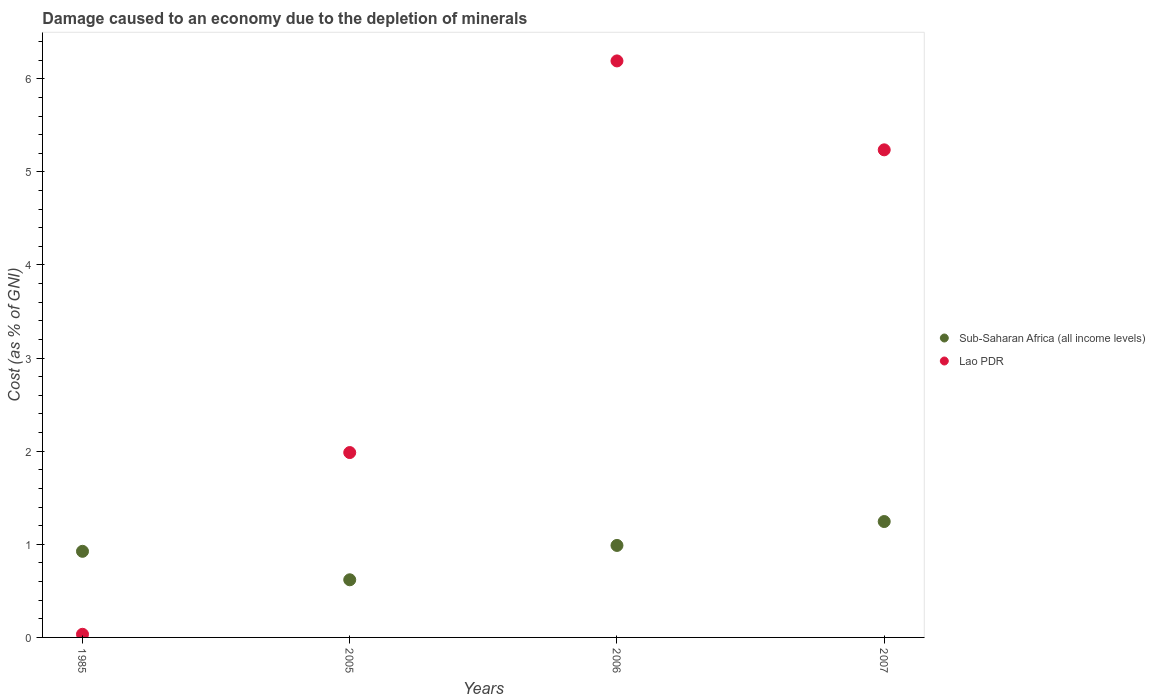How many different coloured dotlines are there?
Your response must be concise. 2. What is the cost of damage caused due to the depletion of minerals in Sub-Saharan Africa (all income levels) in 2005?
Your answer should be compact. 0.62. Across all years, what is the maximum cost of damage caused due to the depletion of minerals in Lao PDR?
Your answer should be compact. 6.19. Across all years, what is the minimum cost of damage caused due to the depletion of minerals in Lao PDR?
Offer a terse response. 0.03. In which year was the cost of damage caused due to the depletion of minerals in Lao PDR maximum?
Your response must be concise. 2006. In which year was the cost of damage caused due to the depletion of minerals in Sub-Saharan Africa (all income levels) minimum?
Provide a succinct answer. 2005. What is the total cost of damage caused due to the depletion of minerals in Lao PDR in the graph?
Make the answer very short. 13.45. What is the difference between the cost of damage caused due to the depletion of minerals in Sub-Saharan Africa (all income levels) in 2005 and that in 2007?
Your answer should be very brief. -0.63. What is the difference between the cost of damage caused due to the depletion of minerals in Sub-Saharan Africa (all income levels) in 1985 and the cost of damage caused due to the depletion of minerals in Lao PDR in 2005?
Provide a short and direct response. -1.06. What is the average cost of damage caused due to the depletion of minerals in Sub-Saharan Africa (all income levels) per year?
Give a very brief answer. 0.94. In the year 2007, what is the difference between the cost of damage caused due to the depletion of minerals in Sub-Saharan Africa (all income levels) and cost of damage caused due to the depletion of minerals in Lao PDR?
Your answer should be compact. -3.99. In how many years, is the cost of damage caused due to the depletion of minerals in Sub-Saharan Africa (all income levels) greater than 2.6 %?
Offer a terse response. 0. What is the ratio of the cost of damage caused due to the depletion of minerals in Sub-Saharan Africa (all income levels) in 1985 to that in 2005?
Give a very brief answer. 1.49. Is the cost of damage caused due to the depletion of minerals in Sub-Saharan Africa (all income levels) in 2005 less than that in 2006?
Keep it short and to the point. Yes. Is the difference between the cost of damage caused due to the depletion of minerals in Sub-Saharan Africa (all income levels) in 2005 and 2007 greater than the difference between the cost of damage caused due to the depletion of minerals in Lao PDR in 2005 and 2007?
Make the answer very short. Yes. What is the difference between the highest and the second highest cost of damage caused due to the depletion of minerals in Lao PDR?
Offer a terse response. 0.95. What is the difference between the highest and the lowest cost of damage caused due to the depletion of minerals in Sub-Saharan Africa (all income levels)?
Your answer should be compact. 0.63. In how many years, is the cost of damage caused due to the depletion of minerals in Lao PDR greater than the average cost of damage caused due to the depletion of minerals in Lao PDR taken over all years?
Ensure brevity in your answer.  2. Is the sum of the cost of damage caused due to the depletion of minerals in Lao PDR in 2005 and 2006 greater than the maximum cost of damage caused due to the depletion of minerals in Sub-Saharan Africa (all income levels) across all years?
Offer a terse response. Yes. Does the cost of damage caused due to the depletion of minerals in Sub-Saharan Africa (all income levels) monotonically increase over the years?
Provide a succinct answer. No. Is the cost of damage caused due to the depletion of minerals in Sub-Saharan Africa (all income levels) strictly greater than the cost of damage caused due to the depletion of minerals in Lao PDR over the years?
Give a very brief answer. No. Is the cost of damage caused due to the depletion of minerals in Sub-Saharan Africa (all income levels) strictly less than the cost of damage caused due to the depletion of minerals in Lao PDR over the years?
Provide a short and direct response. No. How many years are there in the graph?
Offer a terse response. 4. What is the difference between two consecutive major ticks on the Y-axis?
Your answer should be very brief. 1. Does the graph contain grids?
Keep it short and to the point. No. How many legend labels are there?
Keep it short and to the point. 2. What is the title of the graph?
Offer a terse response. Damage caused to an economy due to the depletion of minerals. Does "Norway" appear as one of the legend labels in the graph?
Your answer should be compact. No. What is the label or title of the X-axis?
Provide a succinct answer. Years. What is the label or title of the Y-axis?
Keep it short and to the point. Cost (as % of GNI). What is the Cost (as % of GNI) of Sub-Saharan Africa (all income levels) in 1985?
Offer a terse response. 0.92. What is the Cost (as % of GNI) in Lao PDR in 1985?
Provide a succinct answer. 0.03. What is the Cost (as % of GNI) of Sub-Saharan Africa (all income levels) in 2005?
Your answer should be very brief. 0.62. What is the Cost (as % of GNI) of Lao PDR in 2005?
Ensure brevity in your answer.  1.99. What is the Cost (as % of GNI) of Sub-Saharan Africa (all income levels) in 2006?
Ensure brevity in your answer.  0.99. What is the Cost (as % of GNI) of Lao PDR in 2006?
Make the answer very short. 6.19. What is the Cost (as % of GNI) of Sub-Saharan Africa (all income levels) in 2007?
Keep it short and to the point. 1.24. What is the Cost (as % of GNI) in Lao PDR in 2007?
Offer a terse response. 5.24. Across all years, what is the maximum Cost (as % of GNI) of Sub-Saharan Africa (all income levels)?
Ensure brevity in your answer.  1.24. Across all years, what is the maximum Cost (as % of GNI) in Lao PDR?
Provide a short and direct response. 6.19. Across all years, what is the minimum Cost (as % of GNI) in Sub-Saharan Africa (all income levels)?
Provide a succinct answer. 0.62. Across all years, what is the minimum Cost (as % of GNI) in Lao PDR?
Offer a terse response. 0.03. What is the total Cost (as % of GNI) of Sub-Saharan Africa (all income levels) in the graph?
Provide a succinct answer. 3.78. What is the total Cost (as % of GNI) in Lao PDR in the graph?
Your response must be concise. 13.45. What is the difference between the Cost (as % of GNI) in Sub-Saharan Africa (all income levels) in 1985 and that in 2005?
Your response must be concise. 0.31. What is the difference between the Cost (as % of GNI) of Lao PDR in 1985 and that in 2005?
Keep it short and to the point. -1.95. What is the difference between the Cost (as % of GNI) in Sub-Saharan Africa (all income levels) in 1985 and that in 2006?
Give a very brief answer. -0.06. What is the difference between the Cost (as % of GNI) of Lao PDR in 1985 and that in 2006?
Give a very brief answer. -6.16. What is the difference between the Cost (as % of GNI) in Sub-Saharan Africa (all income levels) in 1985 and that in 2007?
Make the answer very short. -0.32. What is the difference between the Cost (as % of GNI) of Lao PDR in 1985 and that in 2007?
Ensure brevity in your answer.  -5.2. What is the difference between the Cost (as % of GNI) of Sub-Saharan Africa (all income levels) in 2005 and that in 2006?
Give a very brief answer. -0.37. What is the difference between the Cost (as % of GNI) in Lao PDR in 2005 and that in 2006?
Keep it short and to the point. -4.21. What is the difference between the Cost (as % of GNI) of Sub-Saharan Africa (all income levels) in 2005 and that in 2007?
Make the answer very short. -0.63. What is the difference between the Cost (as % of GNI) of Lao PDR in 2005 and that in 2007?
Offer a very short reply. -3.25. What is the difference between the Cost (as % of GNI) of Sub-Saharan Africa (all income levels) in 2006 and that in 2007?
Give a very brief answer. -0.26. What is the difference between the Cost (as % of GNI) in Lao PDR in 2006 and that in 2007?
Offer a very short reply. 0.95. What is the difference between the Cost (as % of GNI) in Sub-Saharan Africa (all income levels) in 1985 and the Cost (as % of GNI) in Lao PDR in 2005?
Your response must be concise. -1.06. What is the difference between the Cost (as % of GNI) in Sub-Saharan Africa (all income levels) in 1985 and the Cost (as % of GNI) in Lao PDR in 2006?
Make the answer very short. -5.27. What is the difference between the Cost (as % of GNI) in Sub-Saharan Africa (all income levels) in 1985 and the Cost (as % of GNI) in Lao PDR in 2007?
Ensure brevity in your answer.  -4.31. What is the difference between the Cost (as % of GNI) of Sub-Saharan Africa (all income levels) in 2005 and the Cost (as % of GNI) of Lao PDR in 2006?
Provide a succinct answer. -5.57. What is the difference between the Cost (as % of GNI) of Sub-Saharan Africa (all income levels) in 2005 and the Cost (as % of GNI) of Lao PDR in 2007?
Provide a short and direct response. -4.62. What is the difference between the Cost (as % of GNI) in Sub-Saharan Africa (all income levels) in 2006 and the Cost (as % of GNI) in Lao PDR in 2007?
Your response must be concise. -4.25. What is the average Cost (as % of GNI) in Sub-Saharan Africa (all income levels) per year?
Keep it short and to the point. 0.94. What is the average Cost (as % of GNI) of Lao PDR per year?
Your answer should be very brief. 3.36. In the year 1985, what is the difference between the Cost (as % of GNI) in Sub-Saharan Africa (all income levels) and Cost (as % of GNI) in Lao PDR?
Offer a very short reply. 0.89. In the year 2005, what is the difference between the Cost (as % of GNI) in Sub-Saharan Africa (all income levels) and Cost (as % of GNI) in Lao PDR?
Your answer should be compact. -1.37. In the year 2006, what is the difference between the Cost (as % of GNI) in Sub-Saharan Africa (all income levels) and Cost (as % of GNI) in Lao PDR?
Keep it short and to the point. -5.2. In the year 2007, what is the difference between the Cost (as % of GNI) in Sub-Saharan Africa (all income levels) and Cost (as % of GNI) in Lao PDR?
Make the answer very short. -3.99. What is the ratio of the Cost (as % of GNI) of Sub-Saharan Africa (all income levels) in 1985 to that in 2005?
Provide a succinct answer. 1.49. What is the ratio of the Cost (as % of GNI) in Lao PDR in 1985 to that in 2005?
Provide a succinct answer. 0.02. What is the ratio of the Cost (as % of GNI) of Sub-Saharan Africa (all income levels) in 1985 to that in 2006?
Your response must be concise. 0.94. What is the ratio of the Cost (as % of GNI) in Lao PDR in 1985 to that in 2006?
Your answer should be compact. 0.01. What is the ratio of the Cost (as % of GNI) in Sub-Saharan Africa (all income levels) in 1985 to that in 2007?
Provide a succinct answer. 0.74. What is the ratio of the Cost (as % of GNI) of Lao PDR in 1985 to that in 2007?
Make the answer very short. 0.01. What is the ratio of the Cost (as % of GNI) of Sub-Saharan Africa (all income levels) in 2005 to that in 2006?
Ensure brevity in your answer.  0.63. What is the ratio of the Cost (as % of GNI) of Lao PDR in 2005 to that in 2006?
Make the answer very short. 0.32. What is the ratio of the Cost (as % of GNI) in Sub-Saharan Africa (all income levels) in 2005 to that in 2007?
Your response must be concise. 0.5. What is the ratio of the Cost (as % of GNI) of Lao PDR in 2005 to that in 2007?
Make the answer very short. 0.38. What is the ratio of the Cost (as % of GNI) in Sub-Saharan Africa (all income levels) in 2006 to that in 2007?
Offer a terse response. 0.79. What is the ratio of the Cost (as % of GNI) of Lao PDR in 2006 to that in 2007?
Offer a very short reply. 1.18. What is the difference between the highest and the second highest Cost (as % of GNI) of Sub-Saharan Africa (all income levels)?
Your answer should be compact. 0.26. What is the difference between the highest and the second highest Cost (as % of GNI) of Lao PDR?
Your answer should be compact. 0.95. What is the difference between the highest and the lowest Cost (as % of GNI) of Sub-Saharan Africa (all income levels)?
Give a very brief answer. 0.63. What is the difference between the highest and the lowest Cost (as % of GNI) in Lao PDR?
Your response must be concise. 6.16. 